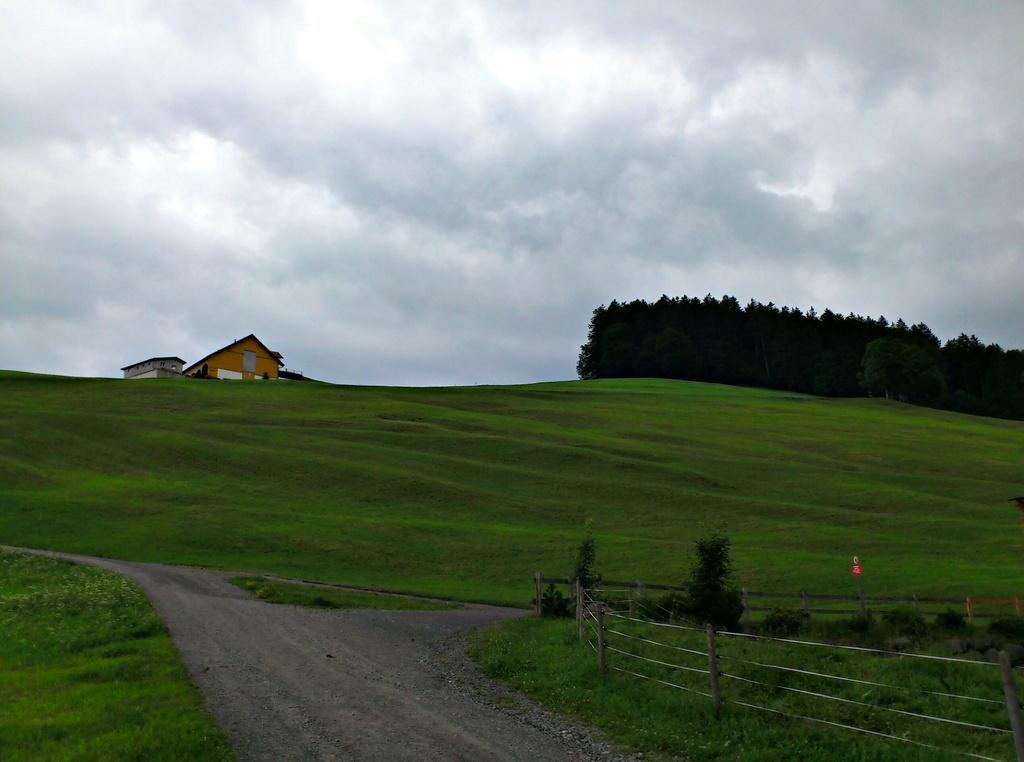Could you give a brief overview of what you see in this image? In the center of the image there is a road. In the background of the image there is house. There are trees. To the right side of the image there is fencing. There is grass. In the background of the image there is sky and clouds. 